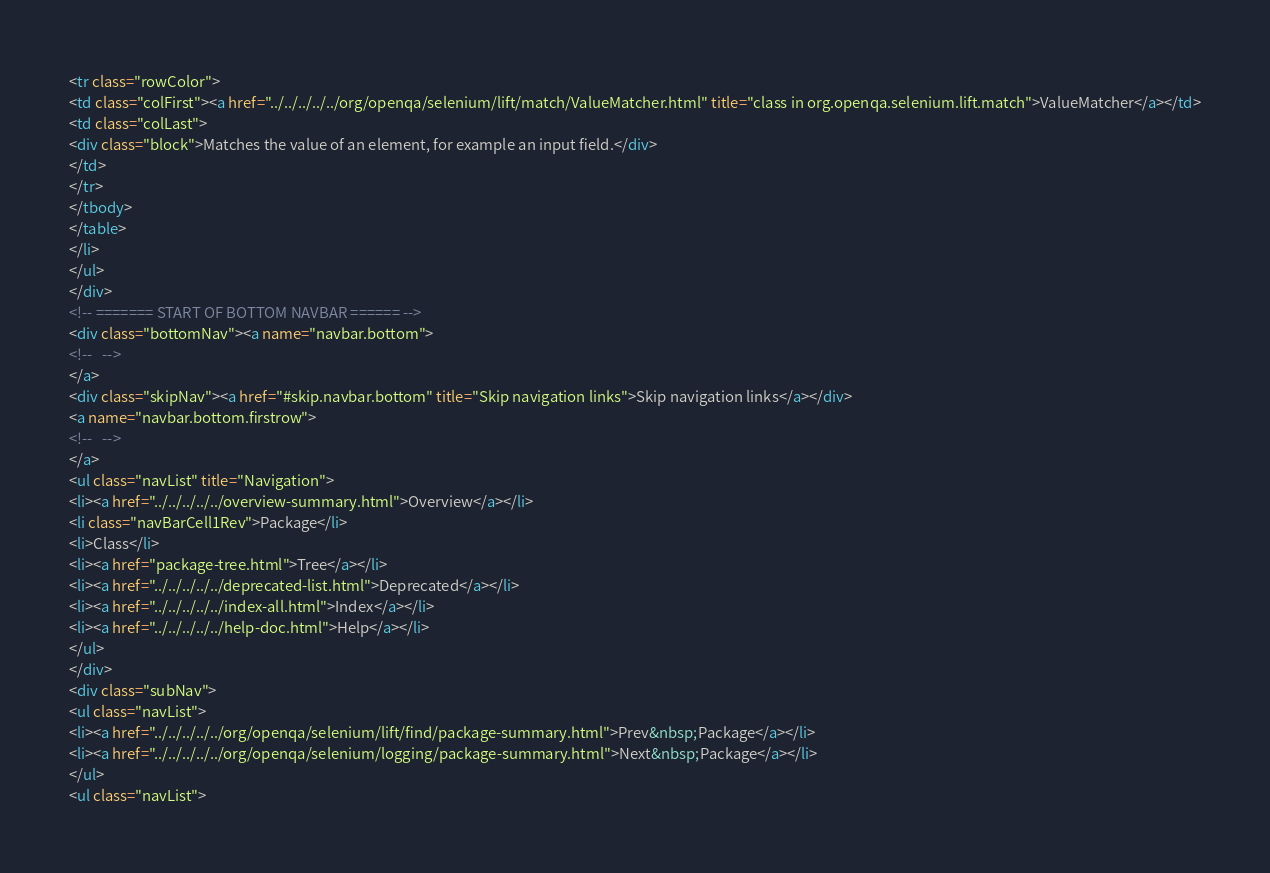Convert code to text. <code><loc_0><loc_0><loc_500><loc_500><_HTML_><tr class="rowColor">
<td class="colFirst"><a href="../../../../../org/openqa/selenium/lift/match/ValueMatcher.html" title="class in org.openqa.selenium.lift.match">ValueMatcher</a></td>
<td class="colLast">
<div class="block">Matches the value of an element, for example an input field.</div>
</td>
</tr>
</tbody>
</table>
</li>
</ul>
</div>
<!-- ======= START OF BOTTOM NAVBAR ====== -->
<div class="bottomNav"><a name="navbar.bottom">
<!--   -->
</a>
<div class="skipNav"><a href="#skip.navbar.bottom" title="Skip navigation links">Skip navigation links</a></div>
<a name="navbar.bottom.firstrow">
<!--   -->
</a>
<ul class="navList" title="Navigation">
<li><a href="../../../../../overview-summary.html">Overview</a></li>
<li class="navBarCell1Rev">Package</li>
<li>Class</li>
<li><a href="package-tree.html">Tree</a></li>
<li><a href="../../../../../deprecated-list.html">Deprecated</a></li>
<li><a href="../../../../../index-all.html">Index</a></li>
<li><a href="../../../../../help-doc.html">Help</a></li>
</ul>
</div>
<div class="subNav">
<ul class="navList">
<li><a href="../../../../../org/openqa/selenium/lift/find/package-summary.html">Prev&nbsp;Package</a></li>
<li><a href="../../../../../org/openqa/selenium/logging/package-summary.html">Next&nbsp;Package</a></li>
</ul>
<ul class="navList"></code> 